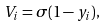Convert formula to latex. <formula><loc_0><loc_0><loc_500><loc_500>V _ { i } = \sigma ( 1 - y _ { i } ) ,</formula> 